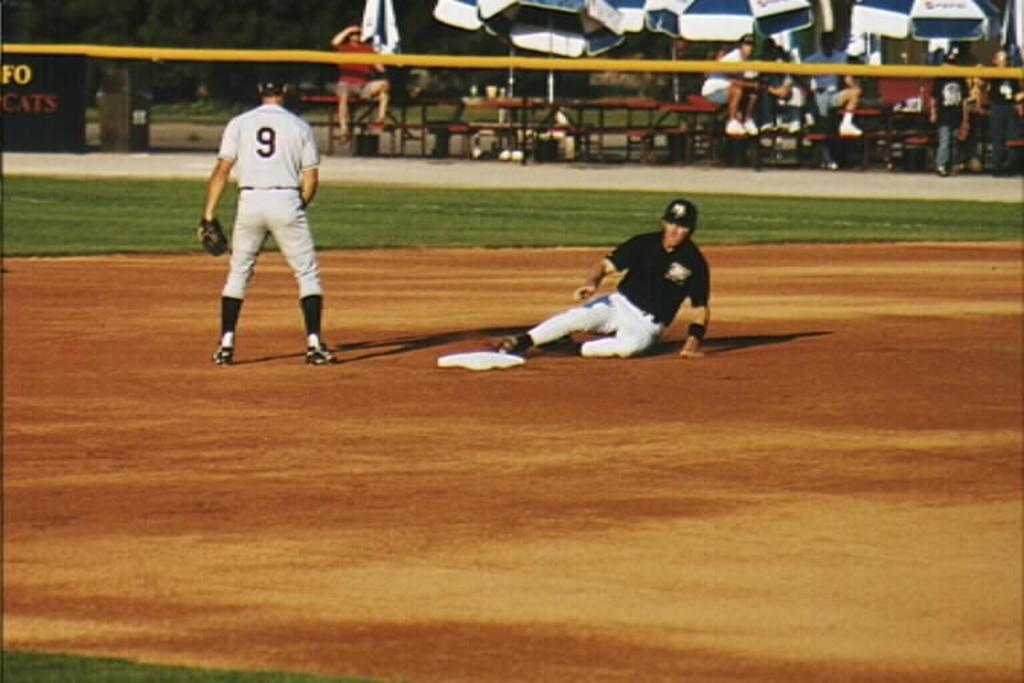<image>
Describe the image concisely. Player number 9 stands near a base as an opponent slides in safe. 